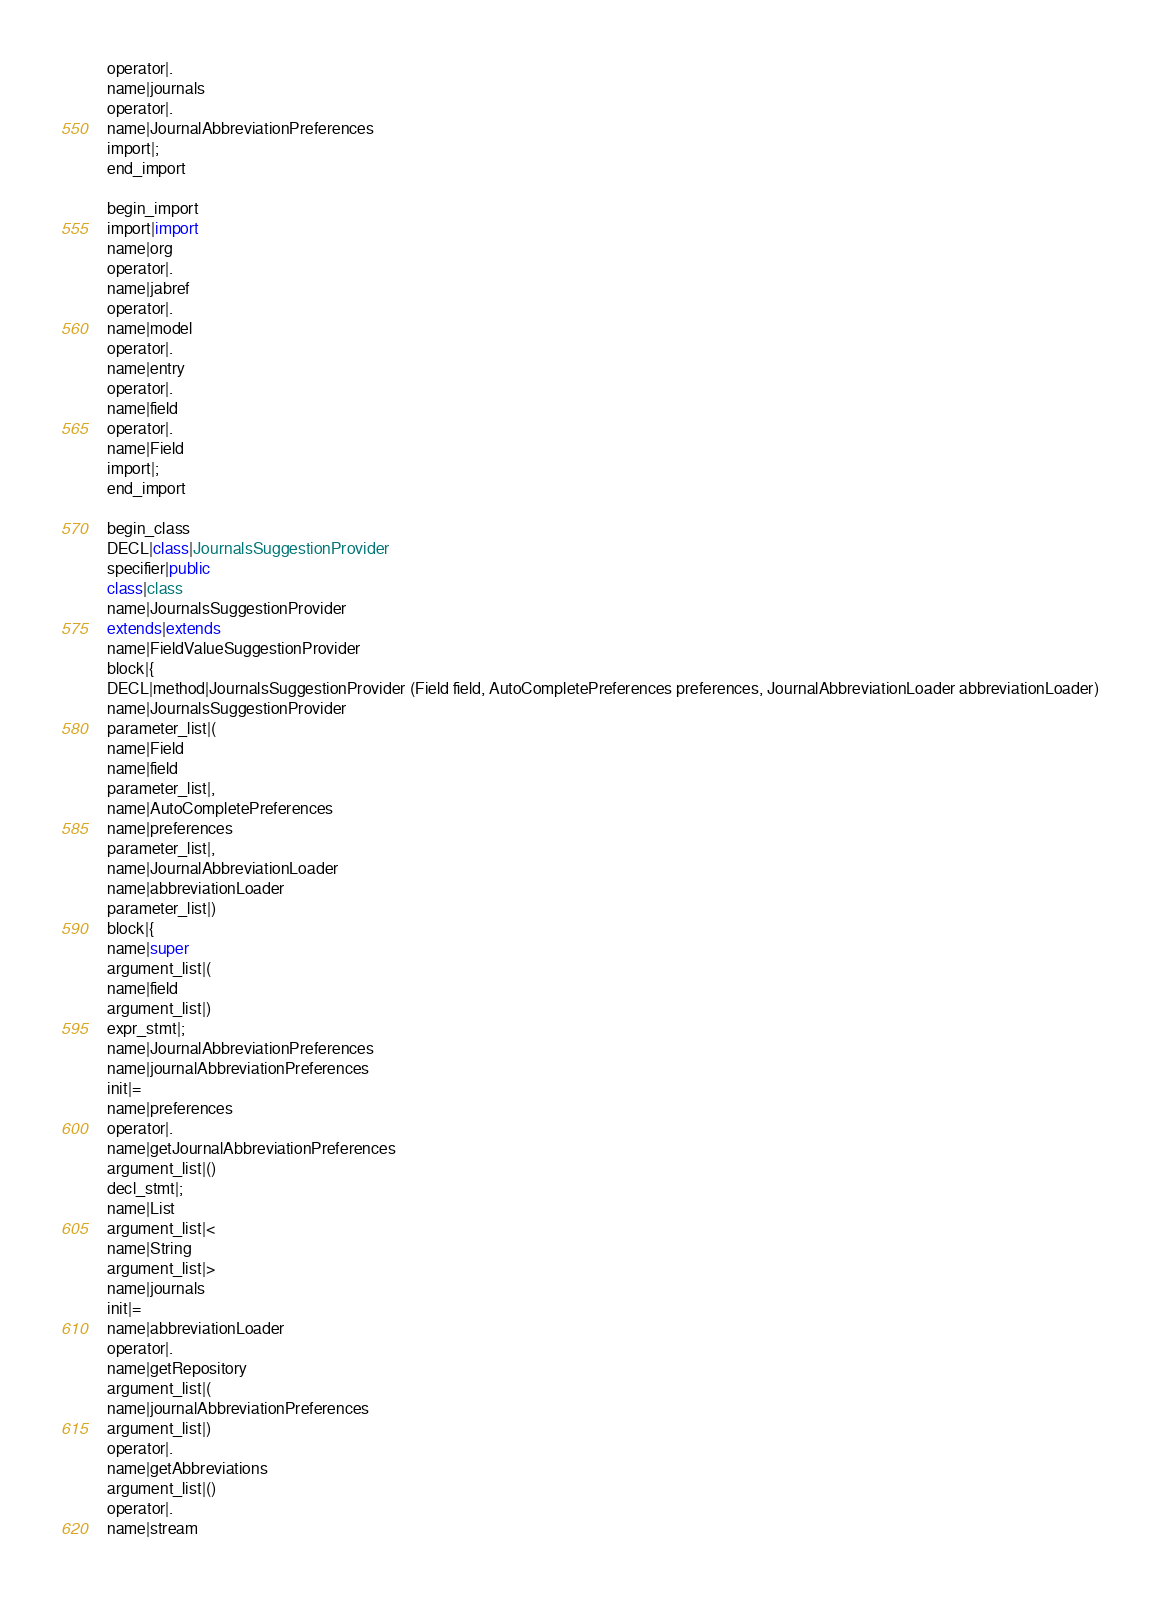Convert code to text. <code><loc_0><loc_0><loc_500><loc_500><_Java_>operator|.
name|journals
operator|.
name|JournalAbbreviationPreferences
import|;
end_import

begin_import
import|import
name|org
operator|.
name|jabref
operator|.
name|model
operator|.
name|entry
operator|.
name|field
operator|.
name|Field
import|;
end_import

begin_class
DECL|class|JournalsSuggestionProvider
specifier|public
class|class
name|JournalsSuggestionProvider
extends|extends
name|FieldValueSuggestionProvider
block|{
DECL|method|JournalsSuggestionProvider (Field field, AutoCompletePreferences preferences, JournalAbbreviationLoader abbreviationLoader)
name|JournalsSuggestionProvider
parameter_list|(
name|Field
name|field
parameter_list|,
name|AutoCompletePreferences
name|preferences
parameter_list|,
name|JournalAbbreviationLoader
name|abbreviationLoader
parameter_list|)
block|{
name|super
argument_list|(
name|field
argument_list|)
expr_stmt|;
name|JournalAbbreviationPreferences
name|journalAbbreviationPreferences
init|=
name|preferences
operator|.
name|getJournalAbbreviationPreferences
argument_list|()
decl_stmt|;
name|List
argument_list|<
name|String
argument_list|>
name|journals
init|=
name|abbreviationLoader
operator|.
name|getRepository
argument_list|(
name|journalAbbreviationPreferences
argument_list|)
operator|.
name|getAbbreviations
argument_list|()
operator|.
name|stream</code> 